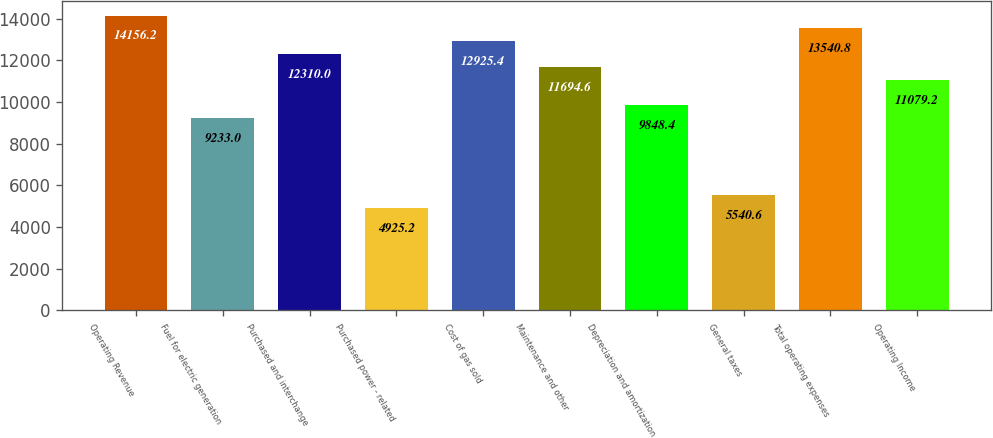<chart> <loc_0><loc_0><loc_500><loc_500><bar_chart><fcel>Operating Revenue<fcel>Fuel for electric generation<fcel>Purchased and interchange<fcel>Purchased power - related<fcel>Cost of gas sold<fcel>Maintenance and other<fcel>Depreciation and amortization<fcel>General taxes<fcel>Total operating expenses<fcel>Operating Income<nl><fcel>14156.2<fcel>9233<fcel>12310<fcel>4925.2<fcel>12925.4<fcel>11694.6<fcel>9848.4<fcel>5540.6<fcel>13540.8<fcel>11079.2<nl></chart> 